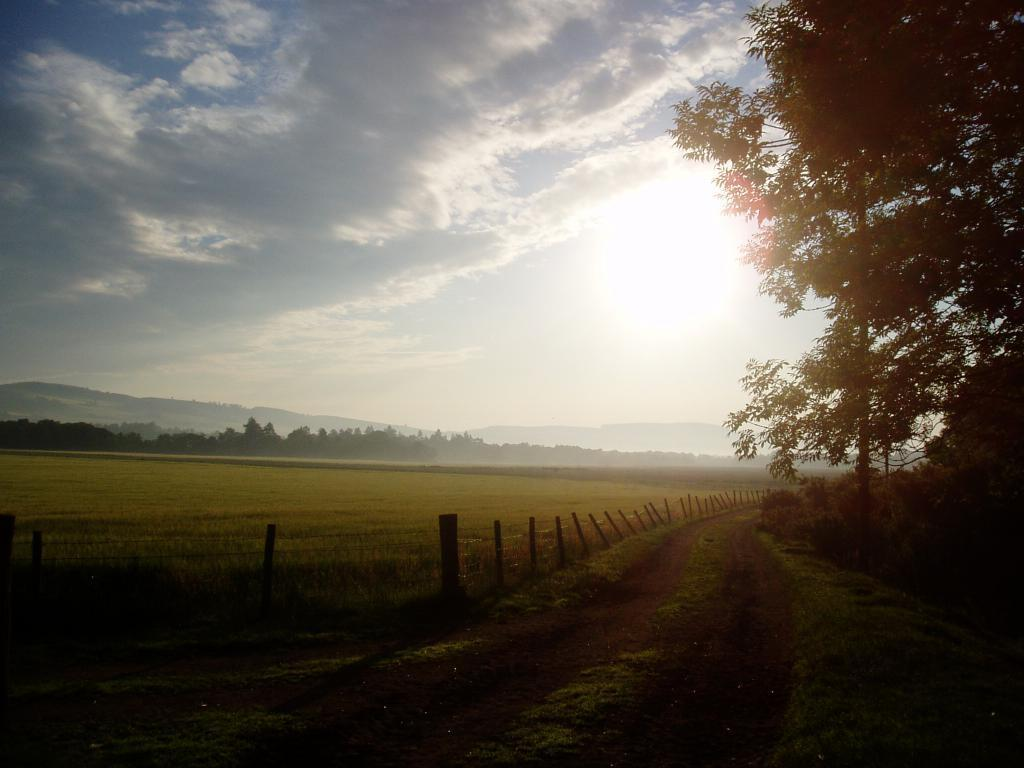What type of vegetation can be seen in the image? There are trees and grass in the image. What kind of surface is visible in the image? There is a pathway in the image. What is located on the left side of the image? There are poles, plants, and a group of trees on the left side of the image. What is visible in the background of the image? The sky is visible in the image. How would you describe the sky in the image? The sky appears cloudy in the image. What type of beef is being served on the chairs in the image? There are no chairs or beef present in the image. What type of wool is being used to make the plants in the image? The plants in the image are not made of wool; they are living organisms. 